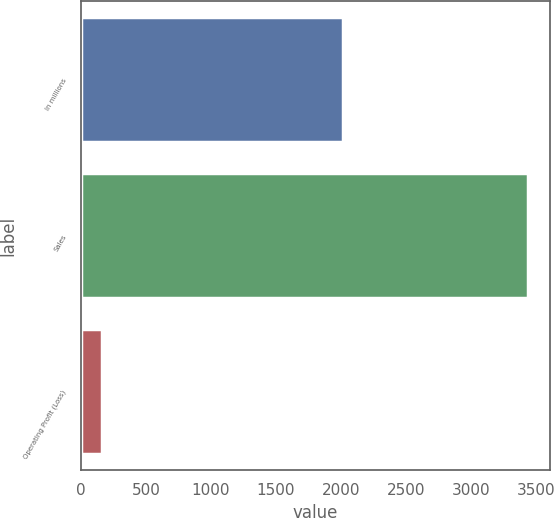Convert chart. <chart><loc_0><loc_0><loc_500><loc_500><bar_chart><fcel>In millions<fcel>Sales<fcel>Operating Profit (Loss)<nl><fcel>2013<fcel>3435<fcel>161<nl></chart> 